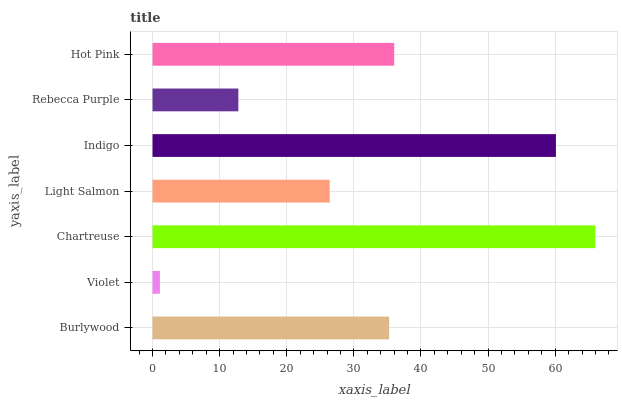Is Violet the minimum?
Answer yes or no. Yes. Is Chartreuse the maximum?
Answer yes or no. Yes. Is Chartreuse the minimum?
Answer yes or no. No. Is Violet the maximum?
Answer yes or no. No. Is Chartreuse greater than Violet?
Answer yes or no. Yes. Is Violet less than Chartreuse?
Answer yes or no. Yes. Is Violet greater than Chartreuse?
Answer yes or no. No. Is Chartreuse less than Violet?
Answer yes or no. No. Is Burlywood the high median?
Answer yes or no. Yes. Is Burlywood the low median?
Answer yes or no. Yes. Is Hot Pink the high median?
Answer yes or no. No. Is Indigo the low median?
Answer yes or no. No. 